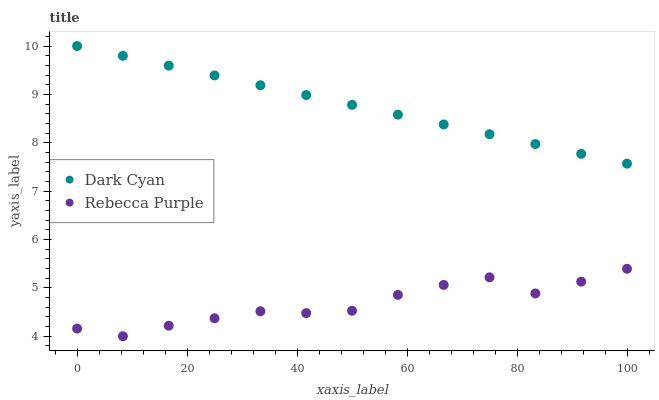Does Rebecca Purple have the minimum area under the curve?
Answer yes or no. Yes. Does Dark Cyan have the maximum area under the curve?
Answer yes or no. Yes. Does Rebecca Purple have the maximum area under the curve?
Answer yes or no. No. Is Dark Cyan the smoothest?
Answer yes or no. Yes. Is Rebecca Purple the roughest?
Answer yes or no. Yes. Is Rebecca Purple the smoothest?
Answer yes or no. No. Does Rebecca Purple have the lowest value?
Answer yes or no. Yes. Does Dark Cyan have the highest value?
Answer yes or no. Yes. Does Rebecca Purple have the highest value?
Answer yes or no. No. Is Rebecca Purple less than Dark Cyan?
Answer yes or no. Yes. Is Dark Cyan greater than Rebecca Purple?
Answer yes or no. Yes. Does Rebecca Purple intersect Dark Cyan?
Answer yes or no. No. 